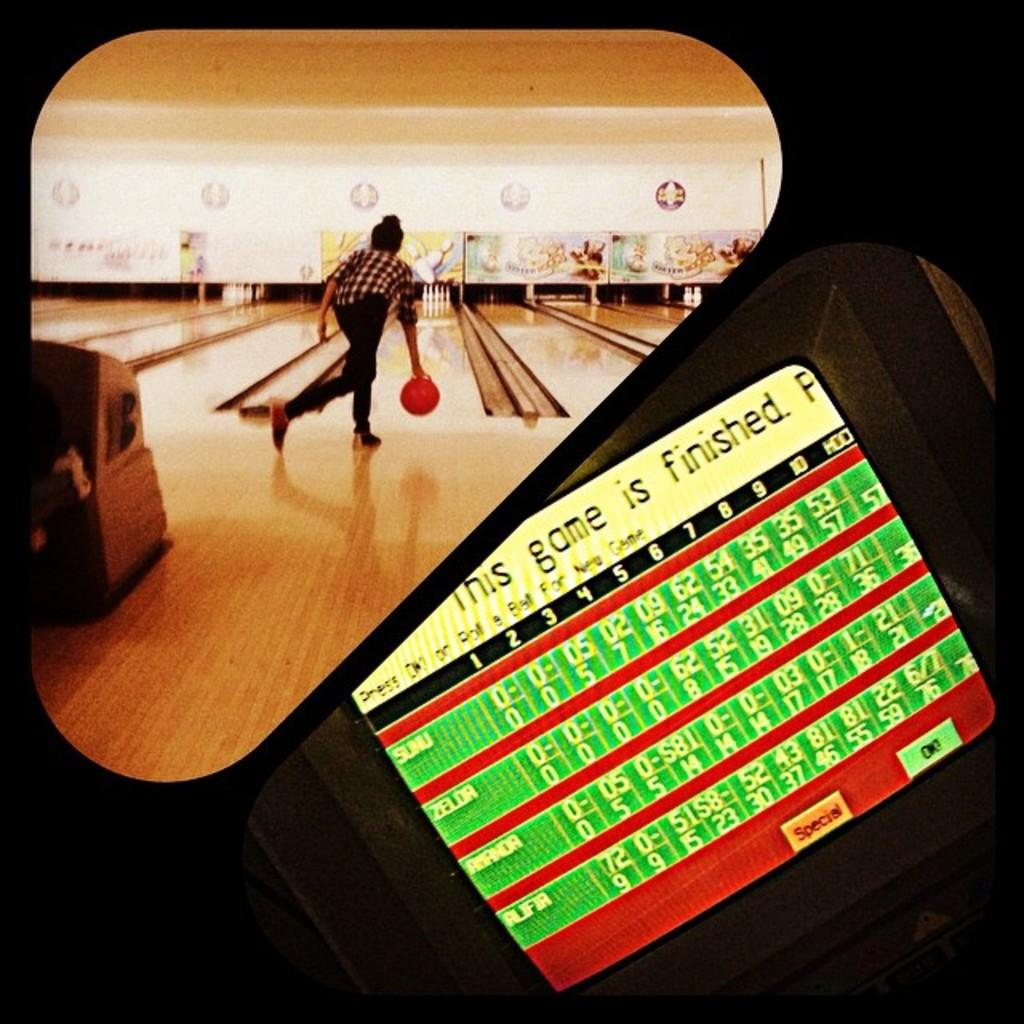What is the main subject of the image? There is a person in the image. What is the person holding in their hand? The person is holding a ball in their hand. What can be seen in the background of the image? There are bowling pins and other unspecified objects in the background of the image. Is there any text or writing visible on the image? Yes, there is text or writing visible on the image. What type of plane can be seen flying in the image? There is no plane visible in the image; it only features a person holding a ball and a background with bowling pins and other unspecified objects. 